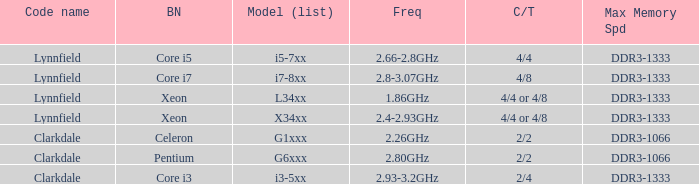What frequency does the Pentium processor use? 2.80GHz. 